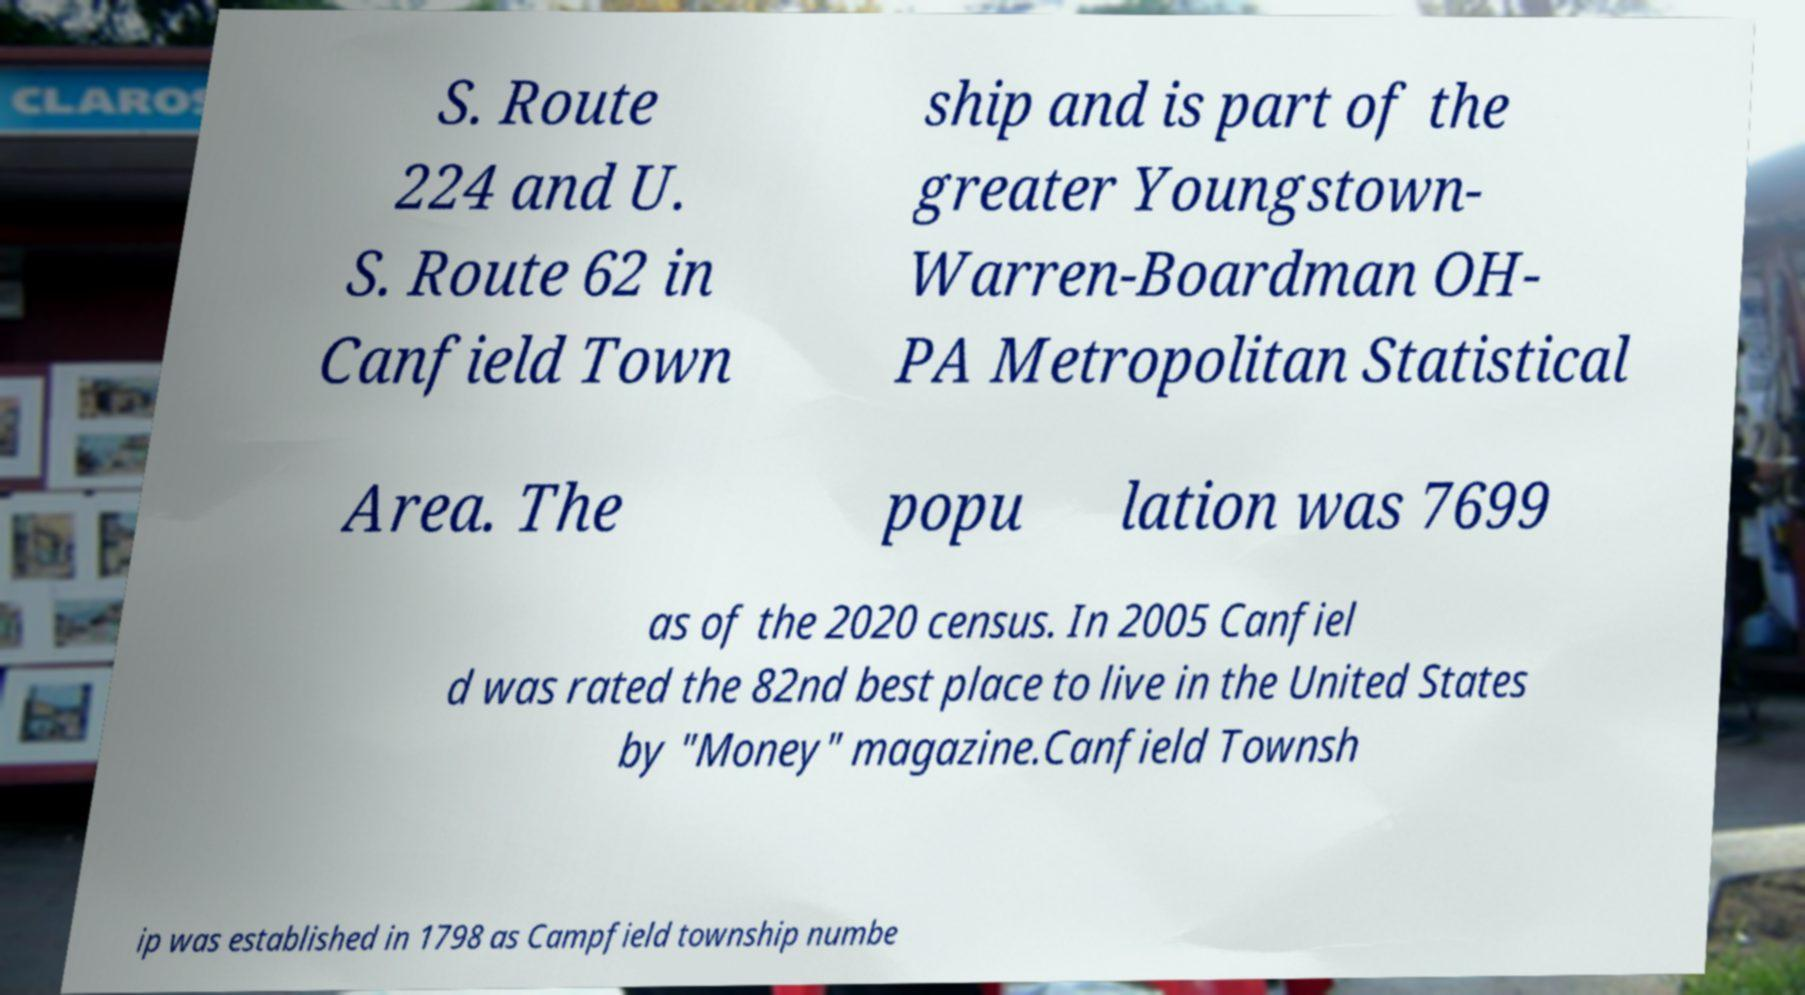Please identify and transcribe the text found in this image. S. Route 224 and U. S. Route 62 in Canfield Town ship and is part of the greater Youngstown- Warren-Boardman OH- PA Metropolitan Statistical Area. The popu lation was 7699 as of the 2020 census. In 2005 Canfiel d was rated the 82nd best place to live in the United States by "Money" magazine.Canfield Townsh ip was established in 1798 as Campfield township numbe 